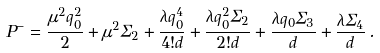Convert formula to latex. <formula><loc_0><loc_0><loc_500><loc_500>P ^ { - } = { \frac { \mu ^ { 2 } q _ { 0 } ^ { 2 } } { 2 } } + \mu ^ { 2 } \Sigma _ { 2 } + { \frac { \lambda q _ { 0 } ^ { 4 } } { 4 ! d } } + { \frac { \lambda q _ { 0 } ^ { 2 } \Sigma _ { 2 } } { 2 ! d } } + { \frac { \lambda q _ { 0 } \Sigma _ { 3 } } { d } } + { \frac { \lambda \Sigma _ { 4 } } { d } } \, .</formula> 